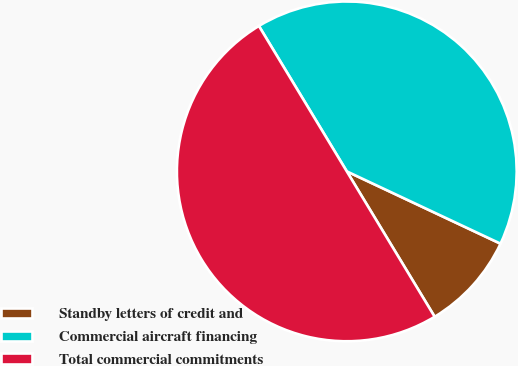<chart> <loc_0><loc_0><loc_500><loc_500><pie_chart><fcel>Standby letters of credit and<fcel>Commercial aircraft financing<fcel>Total commercial commitments<nl><fcel>9.35%<fcel>40.65%<fcel>50.0%<nl></chart> 